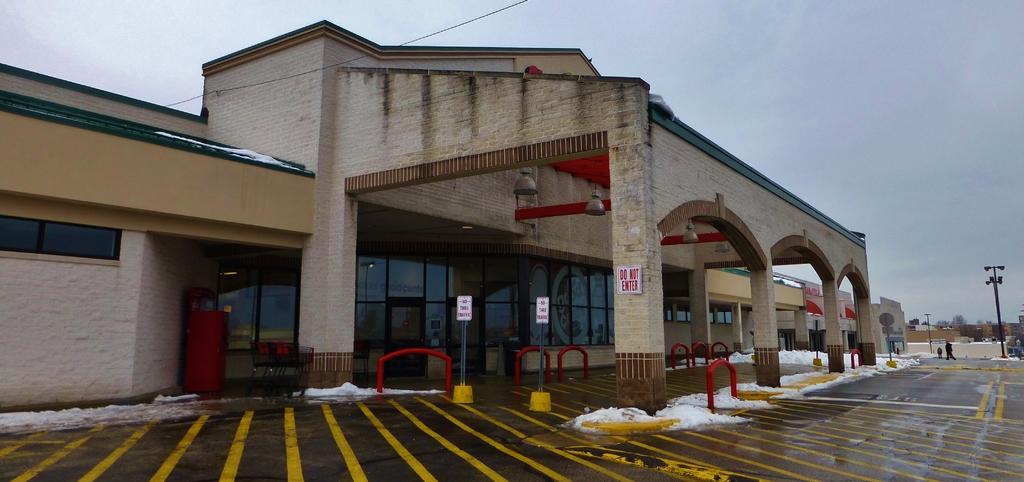What's posted on the white sign on the wall?
Make the answer very short. Do not enter. No text in this image?
Offer a very short reply. No. 